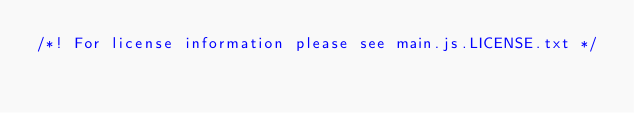<code> <loc_0><loc_0><loc_500><loc_500><_JavaScript_>/*! For license information please see main.js.LICENSE.txt */</code> 